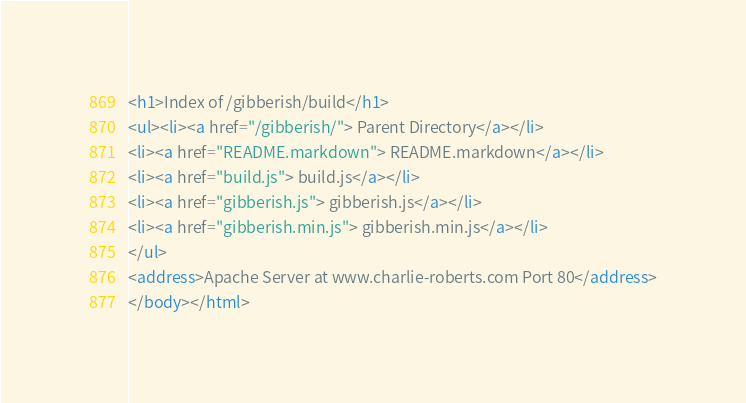<code> <loc_0><loc_0><loc_500><loc_500><_HTML_><h1>Index of /gibberish/build</h1>
<ul><li><a href="/gibberish/"> Parent Directory</a></li>
<li><a href="README.markdown"> README.markdown</a></li>
<li><a href="build.js"> build.js</a></li>
<li><a href="gibberish.js"> gibberish.js</a></li>
<li><a href="gibberish.min.js"> gibberish.min.js</a></li>
</ul>
<address>Apache Server at www.charlie-roberts.com Port 80</address>
</body></html>
</code> 